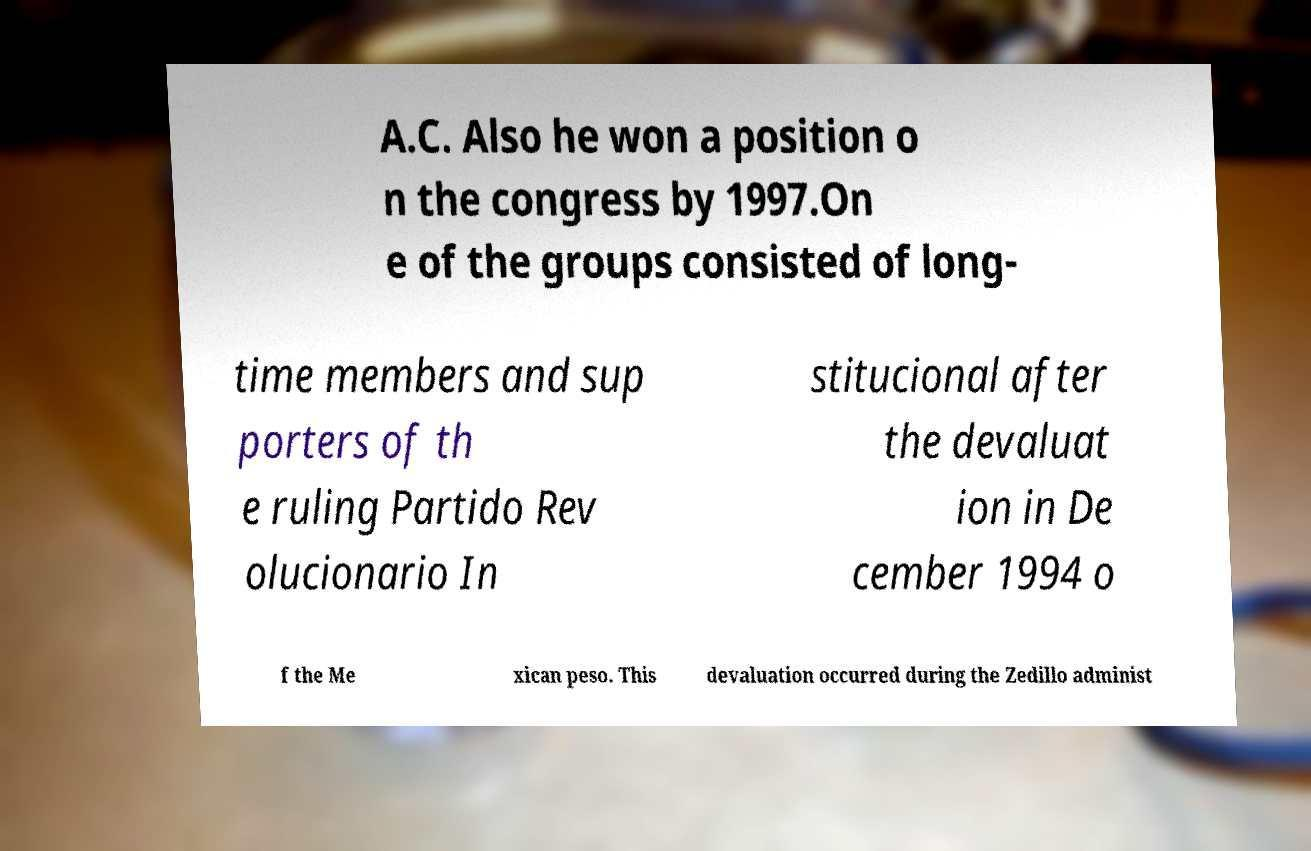Can you read and provide the text displayed in the image?This photo seems to have some interesting text. Can you extract and type it out for me? A.C. Also he won a position o n the congress by 1997.On e of the groups consisted of long- time members and sup porters of th e ruling Partido Rev olucionario In stitucional after the devaluat ion in De cember 1994 o f the Me xican peso. This devaluation occurred during the Zedillo administ 